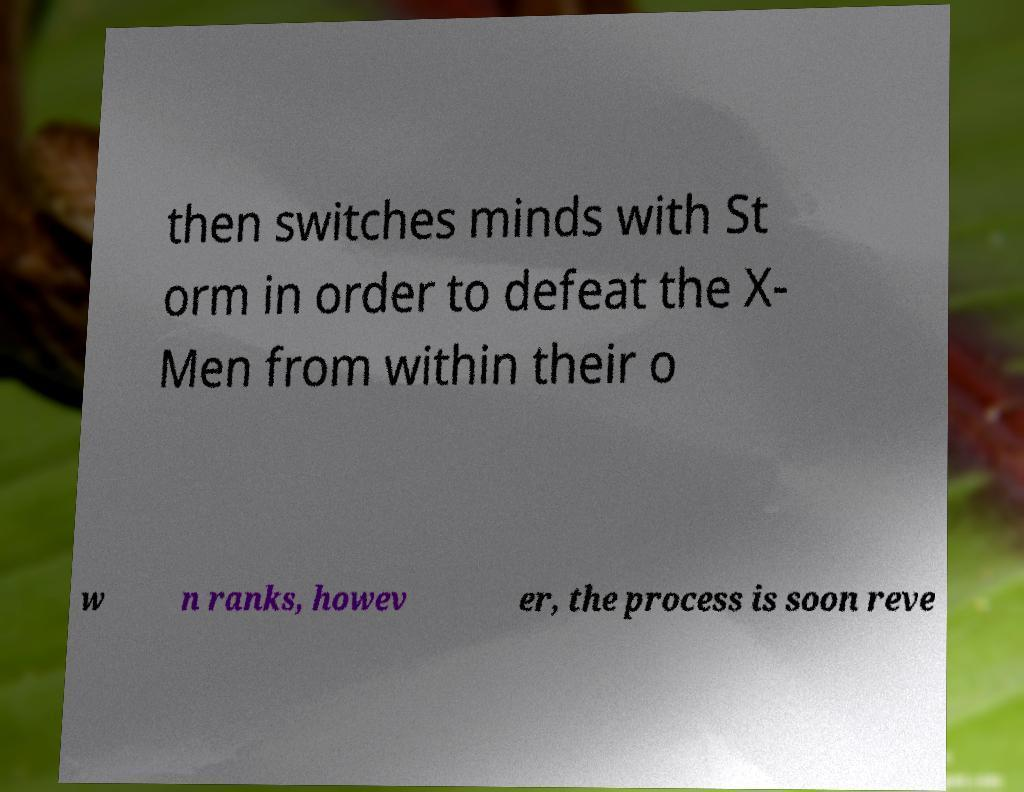Can you accurately transcribe the text from the provided image for me? then switches minds with St orm in order to defeat the X- Men from within their o w n ranks, howev er, the process is soon reve 